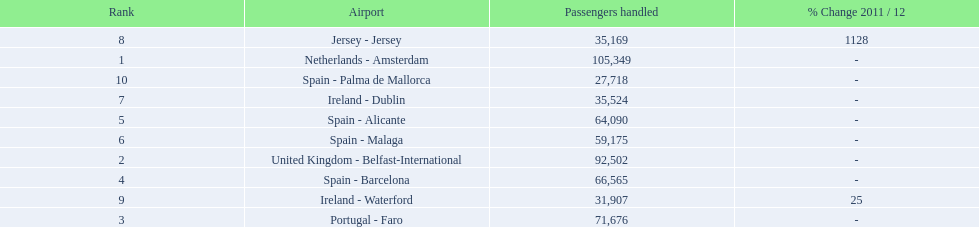What is the best rank? 1. What is the airport? Netherlands - Amsterdam. 